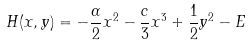Convert formula to latex. <formula><loc_0><loc_0><loc_500><loc_500>H ( x , y ) = - \frac { \alpha } { 2 } x ^ { 2 } - \frac { c } { 3 } x ^ { 3 } + \frac { 1 } { 2 } y ^ { 2 } - E</formula> 